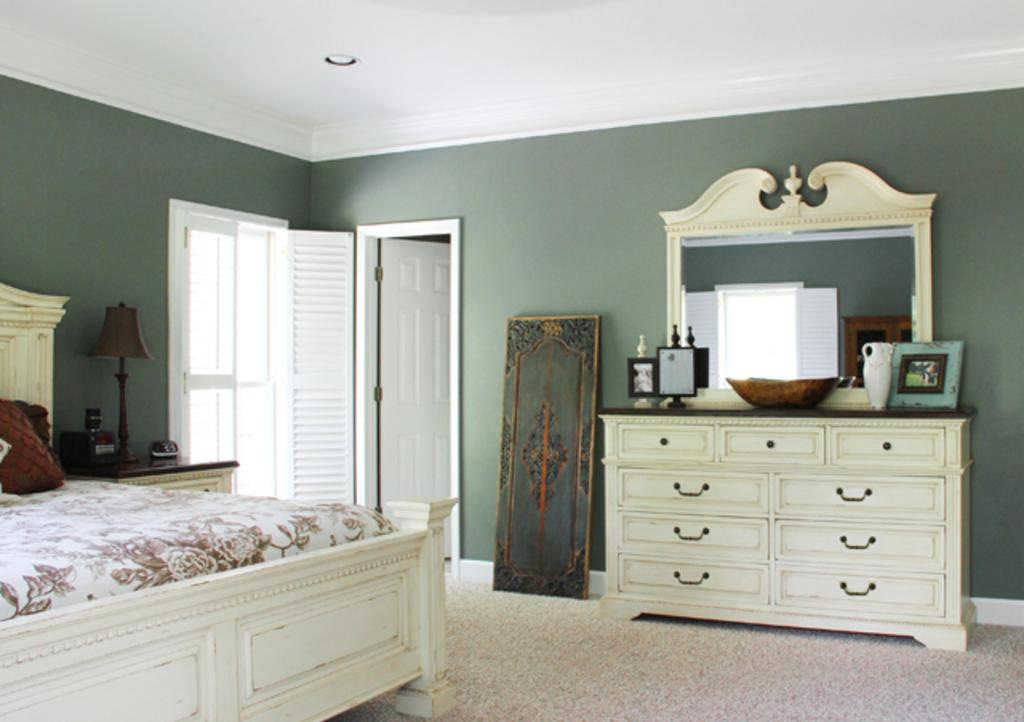What piece of furniture is the main subject in the image? There is a bed in the image. What objects can be seen in the background of the image? There is a lamp, cupboards, a mirror, and doors in the background of the image. What is the color of the doors in the background? The doors are white in color. What is the color of the wall in the background? The wall is green in color. Can you see a volleyball being played in the image? No, there is no volleyball being played in the image. the image features a bed, cupboards, a mirror, and doors in the background. --- Facts: 1. There is a car in the image. 2. The car is red in color. 3. The car has four wheels. 4. The car has a sunroof. 5. The car is parked on the street. Absurd Topics: unicorn, rainbow, stars Conversation: What is the main subject in the image? There is a car in the image. What is the color of the car? The car is red in color. How many wheels does the car have? The car has four wheels. What special feature does the car have? The car has a sunroof. Where is the car located in the image? The car is parked on the street. Reasoning: Let's think step by step in order to produce the conversation. We start by identifying the main subject of the image, which is the car. Next, we describe specific features of the car, such as the color, the number of wheels, and the presence of a sunroof. Then, we observe the location of the car in the image, which is parked on the street. Absurd Question/Answer: Can you see a unicorn in the image? No, there is no unicorn present in the image. --- Facts: 11. There is a group of people in the image. 22. The people are wearing hats. 33. The people are holding hands. 444. The people are standing in front of a building. Absurd Topics: dinosaur, cave, rocks Conversation: What is the main subject in the image? There is a group of people in the image. What are the people wearing on their heads? The people are wearing hats. What are the people doing with their hands? The people are holding hands. Where are the people located in the image? The people are standing in front of a building. Reasoning: Let's think step by step in order to produce the conversation. We start by identifying the main subject of the image, which is the group of people. Next, we describe specific features of the people, such as the type of hats they are wearing and the fact that they are holding 